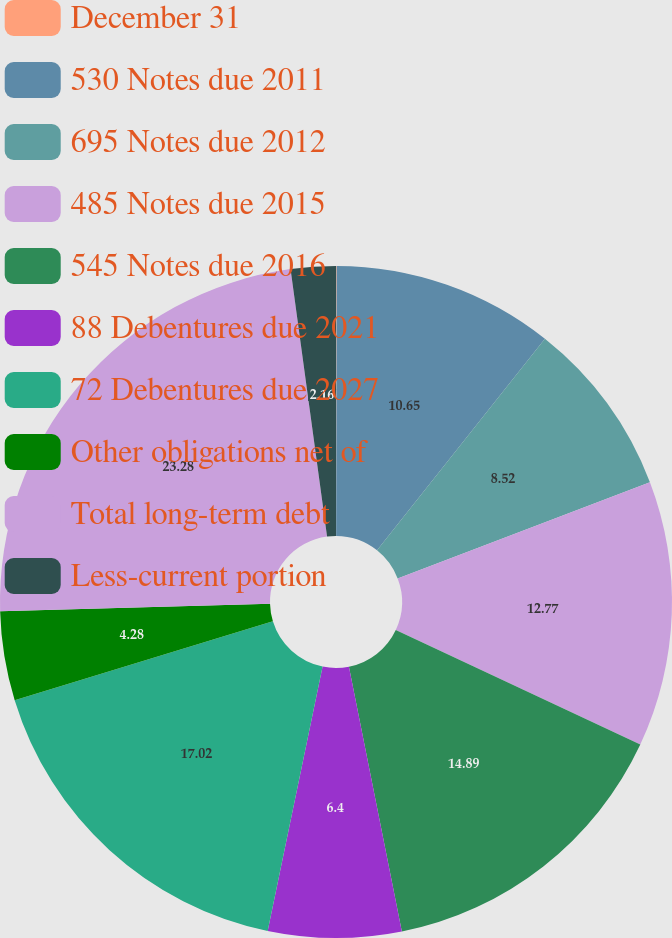Convert chart to OTSL. <chart><loc_0><loc_0><loc_500><loc_500><pie_chart><fcel>December 31<fcel>530 Notes due 2011<fcel>695 Notes due 2012<fcel>485 Notes due 2015<fcel>545 Notes due 2016<fcel>88 Debentures due 2021<fcel>72 Debentures due 2027<fcel>Other obligations net of<fcel>Total long-term debt<fcel>Less-current portion<nl><fcel>0.03%<fcel>10.65%<fcel>8.52%<fcel>12.77%<fcel>14.89%<fcel>6.4%<fcel>17.02%<fcel>4.28%<fcel>23.28%<fcel>2.16%<nl></chart> 